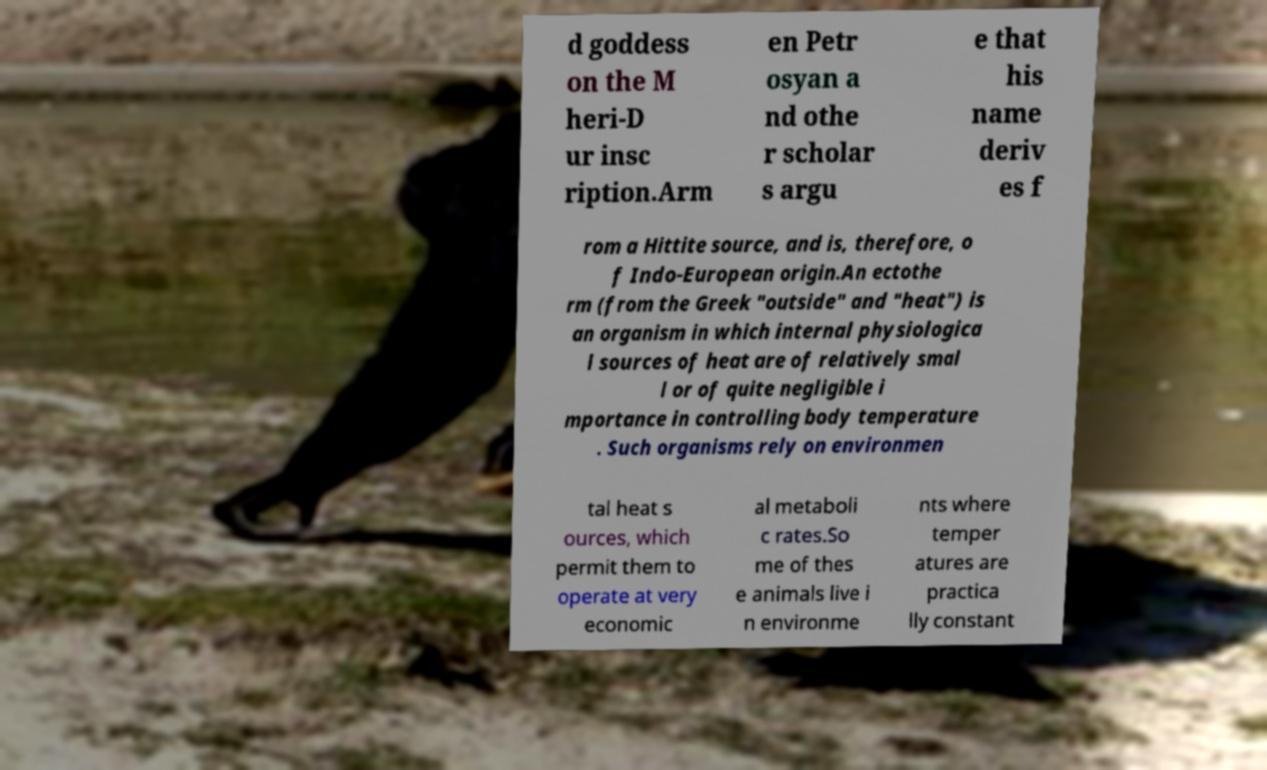Can you accurately transcribe the text from the provided image for me? d goddess on the M heri-D ur insc ription.Arm en Petr osyan a nd othe r scholar s argu e that his name deriv es f rom a Hittite source, and is, therefore, o f Indo-European origin.An ectothe rm (from the Greek "outside" and "heat") is an organism in which internal physiologica l sources of heat are of relatively smal l or of quite negligible i mportance in controlling body temperature . Such organisms rely on environmen tal heat s ources, which permit them to operate at very economic al metaboli c rates.So me of thes e animals live i n environme nts where temper atures are practica lly constant 